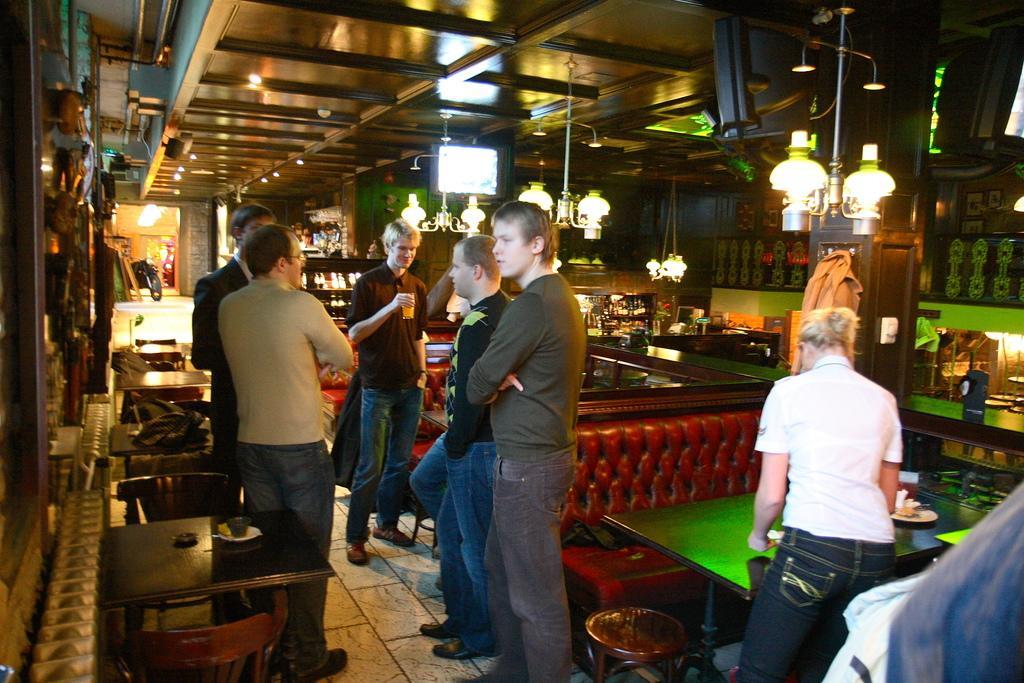Can you describe this image briefly? In this image I can see few person standing. There is a table,chair. At the background there are some objects. 